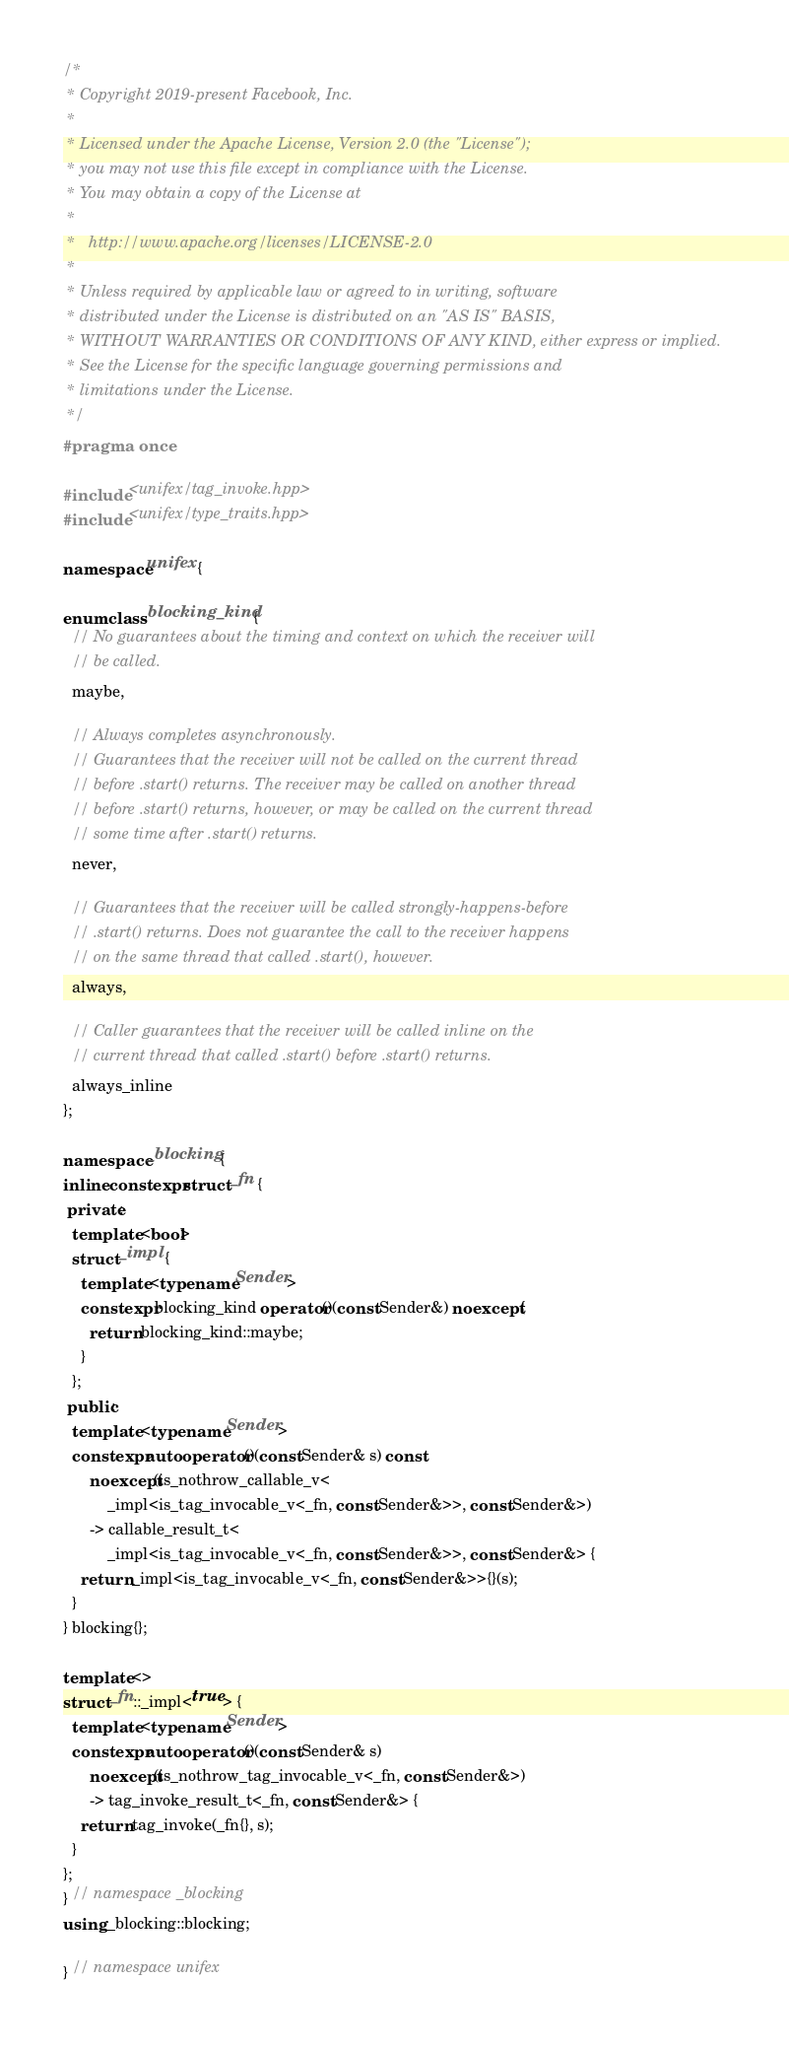<code> <loc_0><loc_0><loc_500><loc_500><_C++_>/*
 * Copyright 2019-present Facebook, Inc.
 *
 * Licensed under the Apache License, Version 2.0 (the "License");
 * you may not use this file except in compliance with the License.
 * You may obtain a copy of the License at
 *
 *   http://www.apache.org/licenses/LICENSE-2.0
 *
 * Unless required by applicable law or agreed to in writing, software
 * distributed under the License is distributed on an "AS IS" BASIS,
 * WITHOUT WARRANTIES OR CONDITIONS OF ANY KIND, either express or implied.
 * See the License for the specific language governing permissions and
 * limitations under the License.
 */
#pragma once

#include <unifex/tag_invoke.hpp>
#include <unifex/type_traits.hpp>

namespace unifex {

enum class blocking_kind {
  // No guarantees about the timing and context on which the receiver will
  // be called.
  maybe,

  // Always completes asynchronously.
  // Guarantees that the receiver will not be called on the current thread
  // before .start() returns. The receiver may be called on another thread
  // before .start() returns, however, or may be called on the current thread
  // some time after .start() returns.
  never,

  // Guarantees that the receiver will be called strongly-happens-before
  // .start() returns. Does not guarantee the call to the receiver happens
  // on the same thread that called .start(), however.
  always,

  // Caller guarantees that the receiver will be called inline on the
  // current thread that called .start() before .start() returns.
  always_inline
};

namespace _blocking {
inline constexpr struct _fn {
 private:
  template <bool>
  struct _impl {
    template <typename Sender>
    constexpr blocking_kind operator()(const Sender&) noexcept {
      return blocking_kind::maybe;
    }
  };
 public:
  template <typename Sender>
  constexpr auto operator()(const Sender& s) const
      noexcept(is_nothrow_callable_v<
          _impl<is_tag_invocable_v<_fn, const Sender&>>, const Sender&>)
      -> callable_result_t<
          _impl<is_tag_invocable_v<_fn, const Sender&>>, const Sender&> {
    return _impl<is_tag_invocable_v<_fn, const Sender&>>{}(s);
  }
} blocking{};

template <>
struct _fn::_impl<true> {
  template <typename Sender>
  constexpr auto operator()(const Sender& s)
      noexcept(is_nothrow_tag_invocable_v<_fn, const Sender&>)
      -> tag_invoke_result_t<_fn, const Sender&> {
    return tag_invoke(_fn{}, s);
  }
};
} // namespace _blocking
using _blocking::blocking;

} // namespace unifex
</code> 